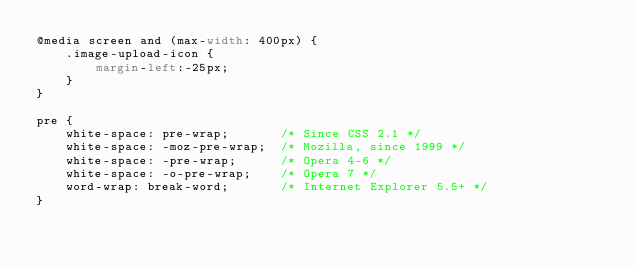Convert code to text. <code><loc_0><loc_0><loc_500><loc_500><_CSS_>@media screen and (max-width: 400px) {
    .image-upload-icon {
        margin-left:-25px;
    }
}

pre {
    white-space: pre-wrap;       /* Since CSS 2.1 */
    white-space: -moz-pre-wrap;  /* Mozilla, since 1999 */
    white-space: -pre-wrap;      /* Opera 4-6 */
    white-space: -o-pre-wrap;    /* Opera 7 */
    word-wrap: break-word;       /* Internet Explorer 5.5+ */
}
</code> 